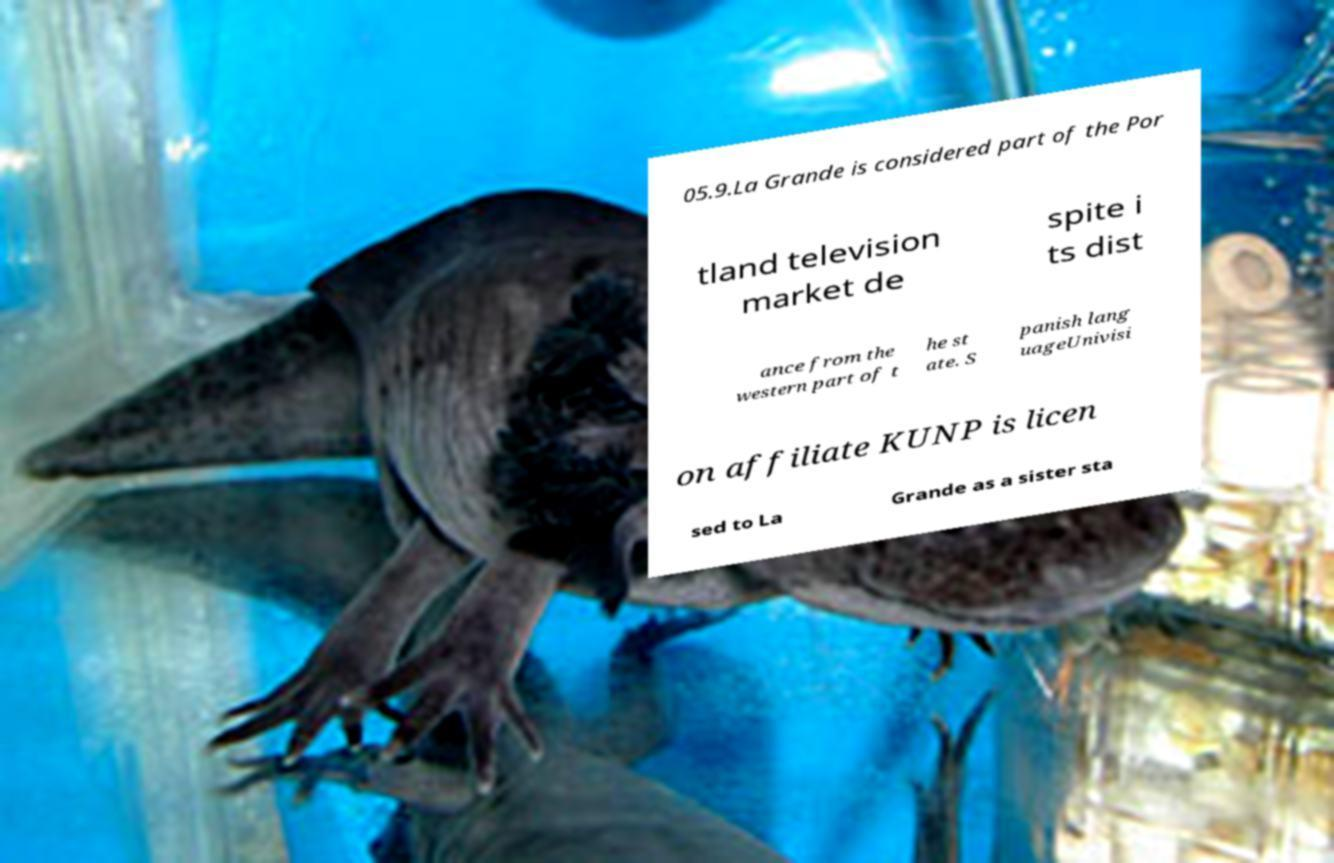Please identify and transcribe the text found in this image. 05.9.La Grande is considered part of the Por tland television market de spite i ts dist ance from the western part of t he st ate. S panish lang uageUnivisi on affiliate KUNP is licen sed to La Grande as a sister sta 